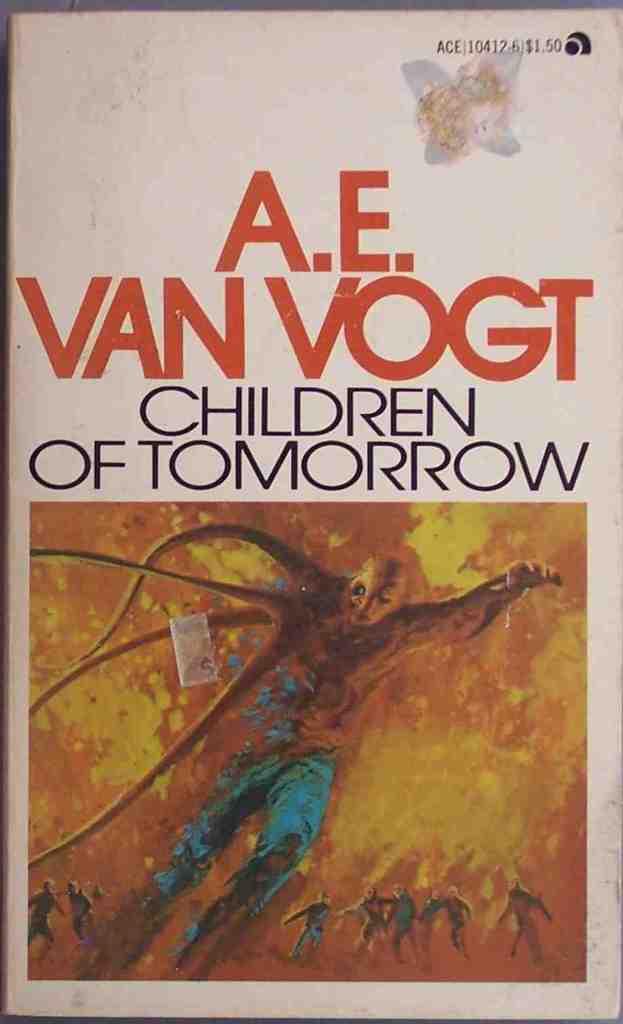What is the title of the book?
Keep it short and to the point. Children of tomorrow. 